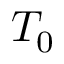<formula> <loc_0><loc_0><loc_500><loc_500>T _ { 0 }</formula> 